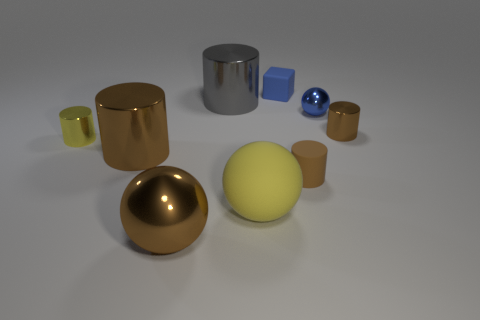What number of large brown metal things have the same shape as the big yellow object?
Offer a terse response. 1. There is a large object that is both in front of the tiny brown metal cylinder and behind the yellow matte sphere; what material is it made of?
Your response must be concise. Metal. There is a tiny ball; what number of small things are in front of it?
Offer a terse response. 3. What number of big cyan shiny objects are there?
Provide a short and direct response. 0. Do the yellow cylinder and the rubber block have the same size?
Keep it short and to the point. Yes. There is a tiny rubber thing behind the large metallic cylinder that is left of the large brown sphere; is there a cylinder that is behind it?
Your answer should be compact. No. There is a yellow thing that is the same shape as the large gray thing; what is it made of?
Your response must be concise. Metal. What color is the big cylinder that is behind the tiny yellow shiny cylinder?
Provide a short and direct response. Gray. How big is the gray cylinder?
Keep it short and to the point. Large. Do the yellow metallic cylinder and the metallic ball to the right of the brown rubber cylinder have the same size?
Your answer should be very brief. Yes. 